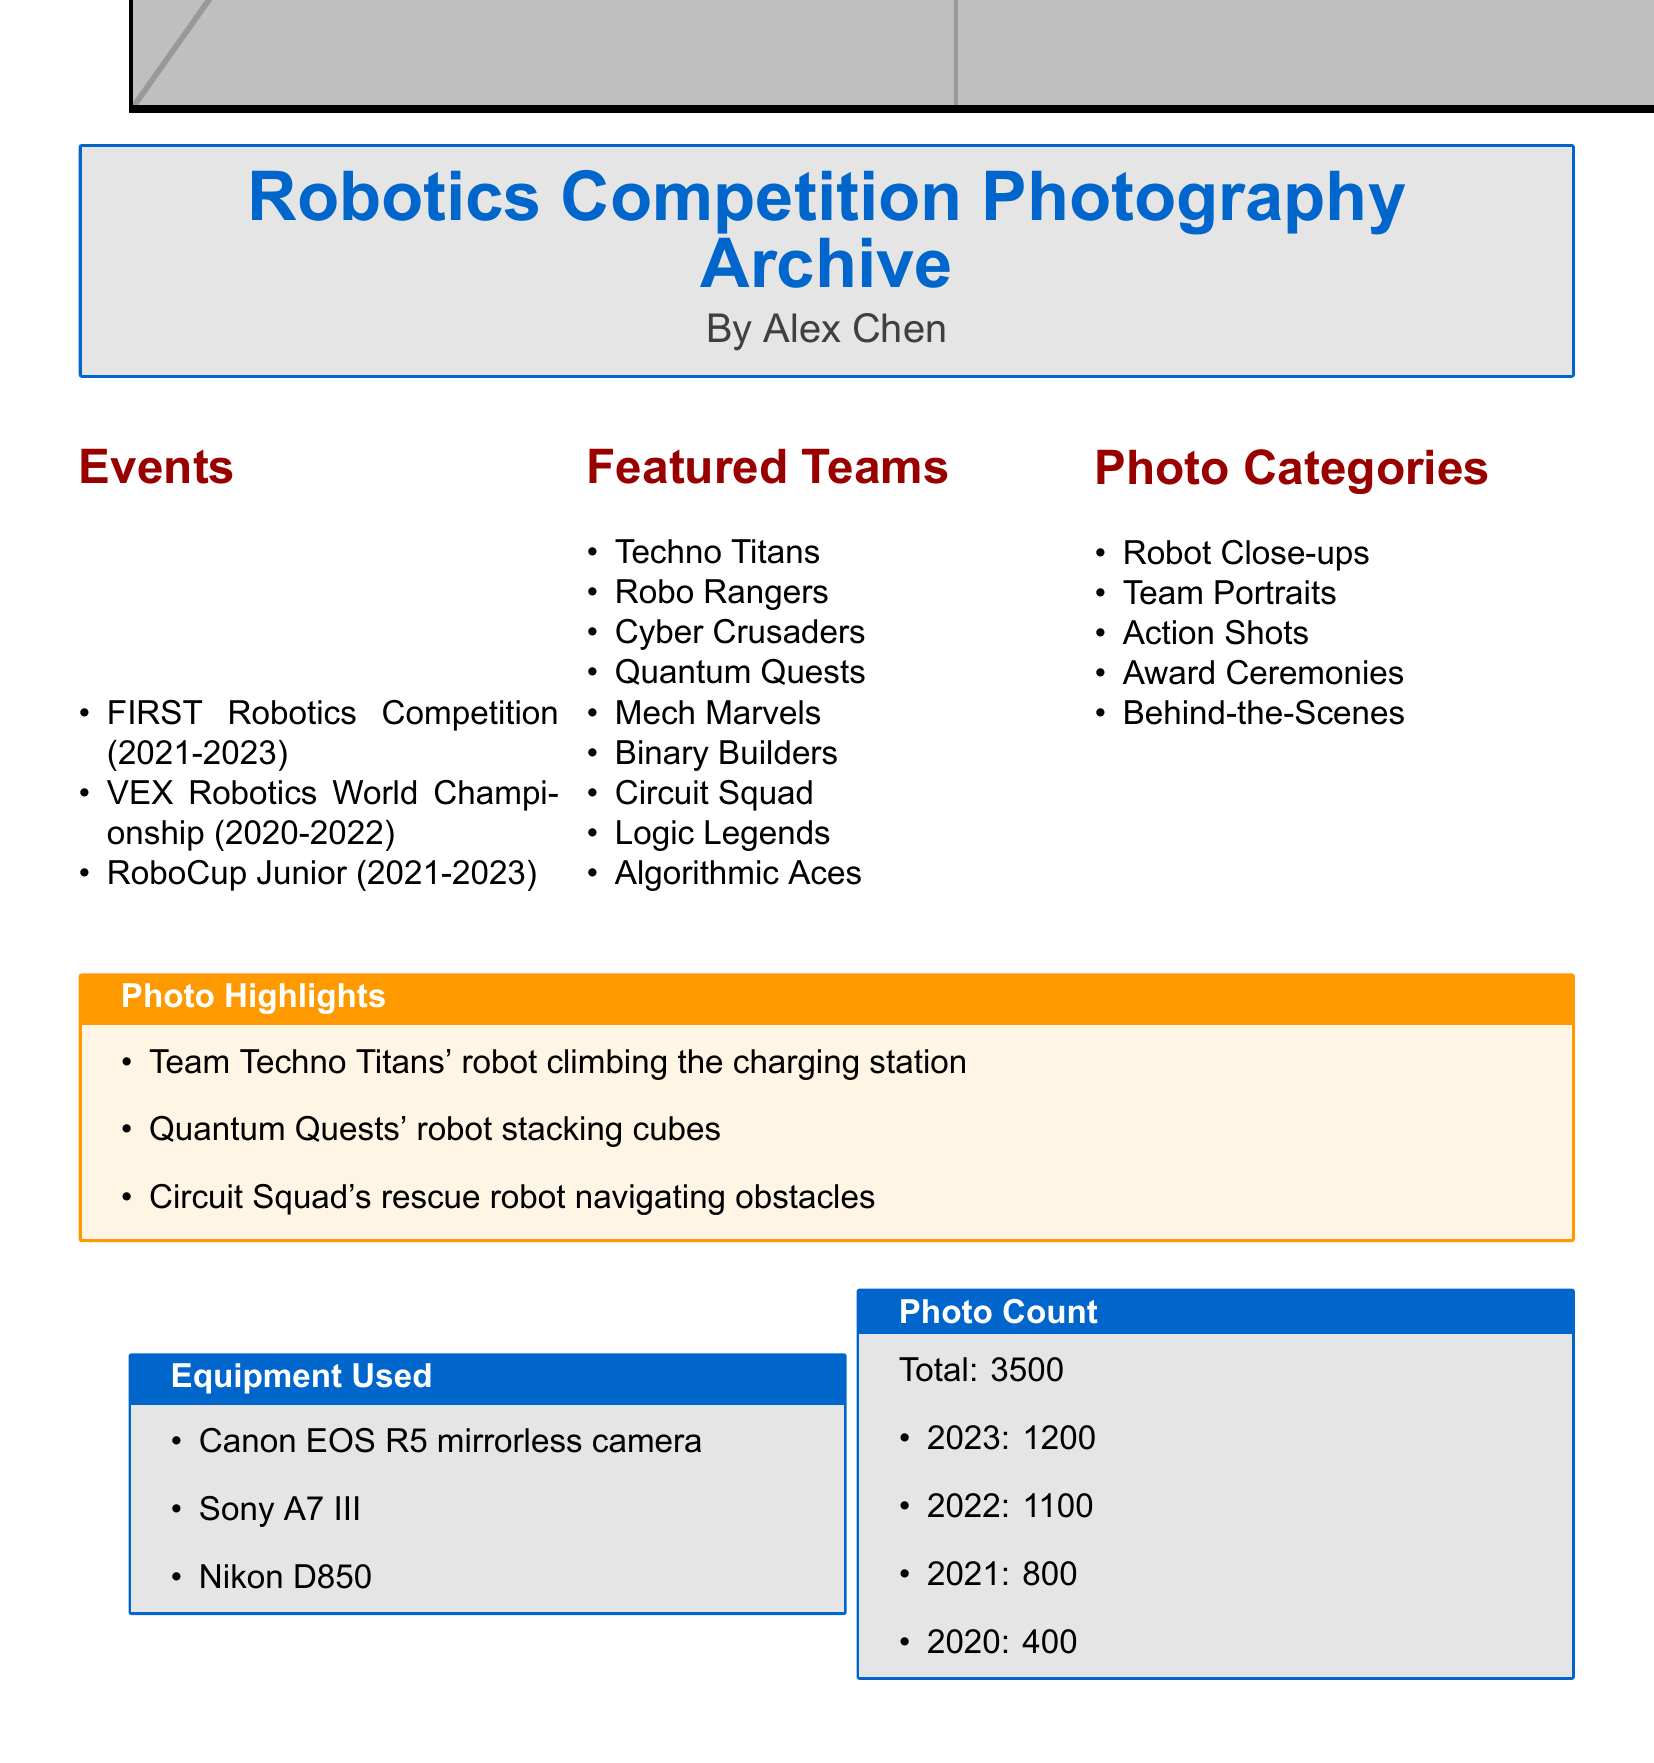what is the total number of photos? The document states that the total number of photos is 3500.
Answer: 3500 which team is featured for stacking cubes? The highlight specifies that Quantum Quests is stacking cubes.
Answer: Quantum Quests how many photos were taken in 2022? The document indicates that 1100 photos were taken in 2022.
Answer: 1100 what event is included in the catalog for the year 2021? The events listed include FIRST Robotics Competition for the years 2021-2023.
Answer: FIRST Robotics Competition how many featured teams are listed in the catalog? The catalog lists a total of nine featured teams.
Answer: 9 which camera model is mentioned first in the equipment used section? The first camera model mentioned is the Canon EOS R5 mirrorless camera.
Answer: Canon EOS R5 list one category of photos documented in the catalog. The document categorizes photos into several types, one of which is Action Shots.
Answer: Action Shots which year has the highest number of documented photos? According to the document, the year with the highest number of photos is 2023.
Answer: 2023 what color is used for the title in the document? The title color is designated as RGB(0,102,204) in the document.
Answer: RGB(0,102,204) 